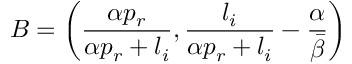Convert formula to latex. <formula><loc_0><loc_0><loc_500><loc_500>B = \left ( \frac { \alpha p _ { r } } { \alpha p _ { r } + l _ { i } } , \frac { l _ { i } } { \alpha p _ { r } + l _ { i } } - \frac { \alpha } { \bar { \beta } } \right )</formula> 